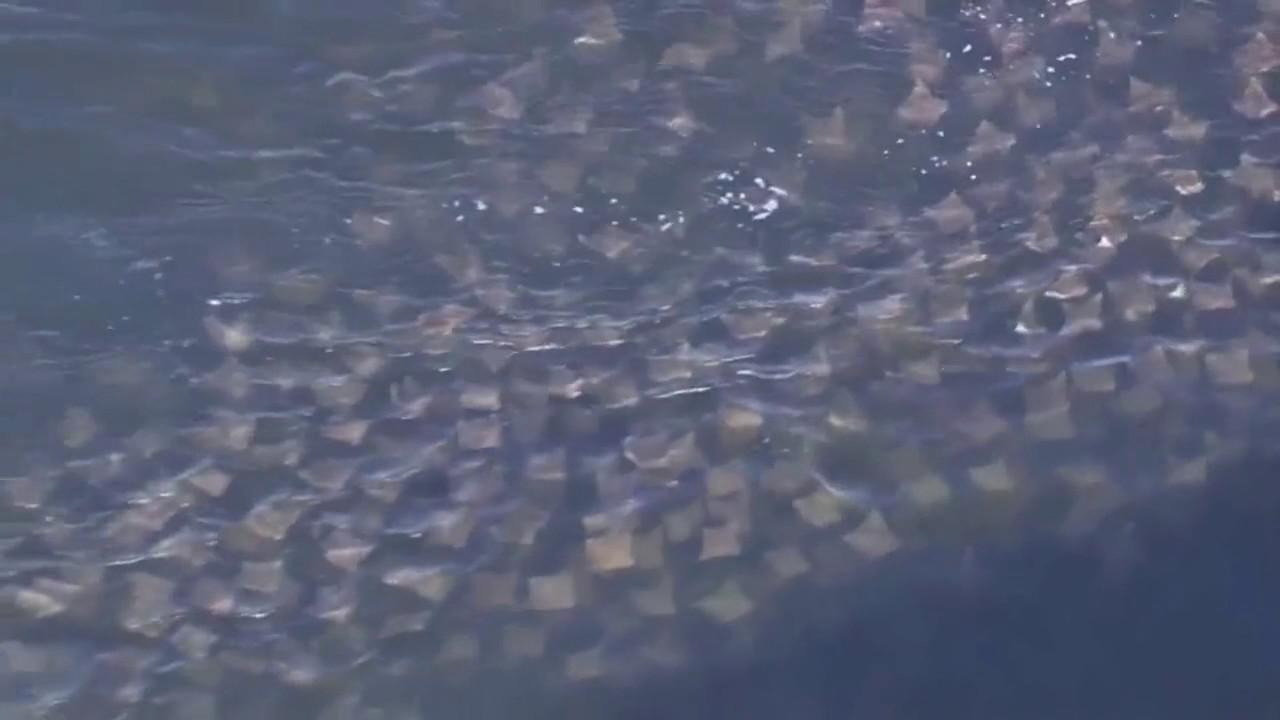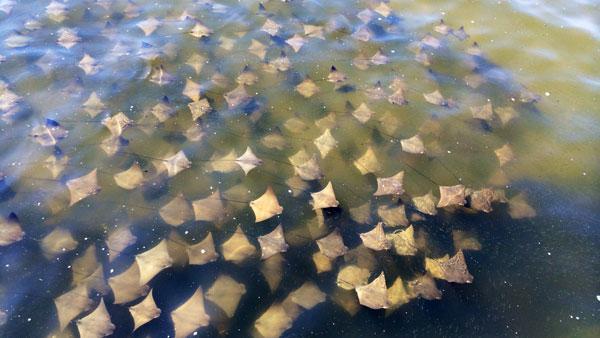The first image is the image on the left, the second image is the image on the right. Analyze the images presented: Is the assertion "A single ray is shown in one of the images." valid? Answer yes or no. No. 